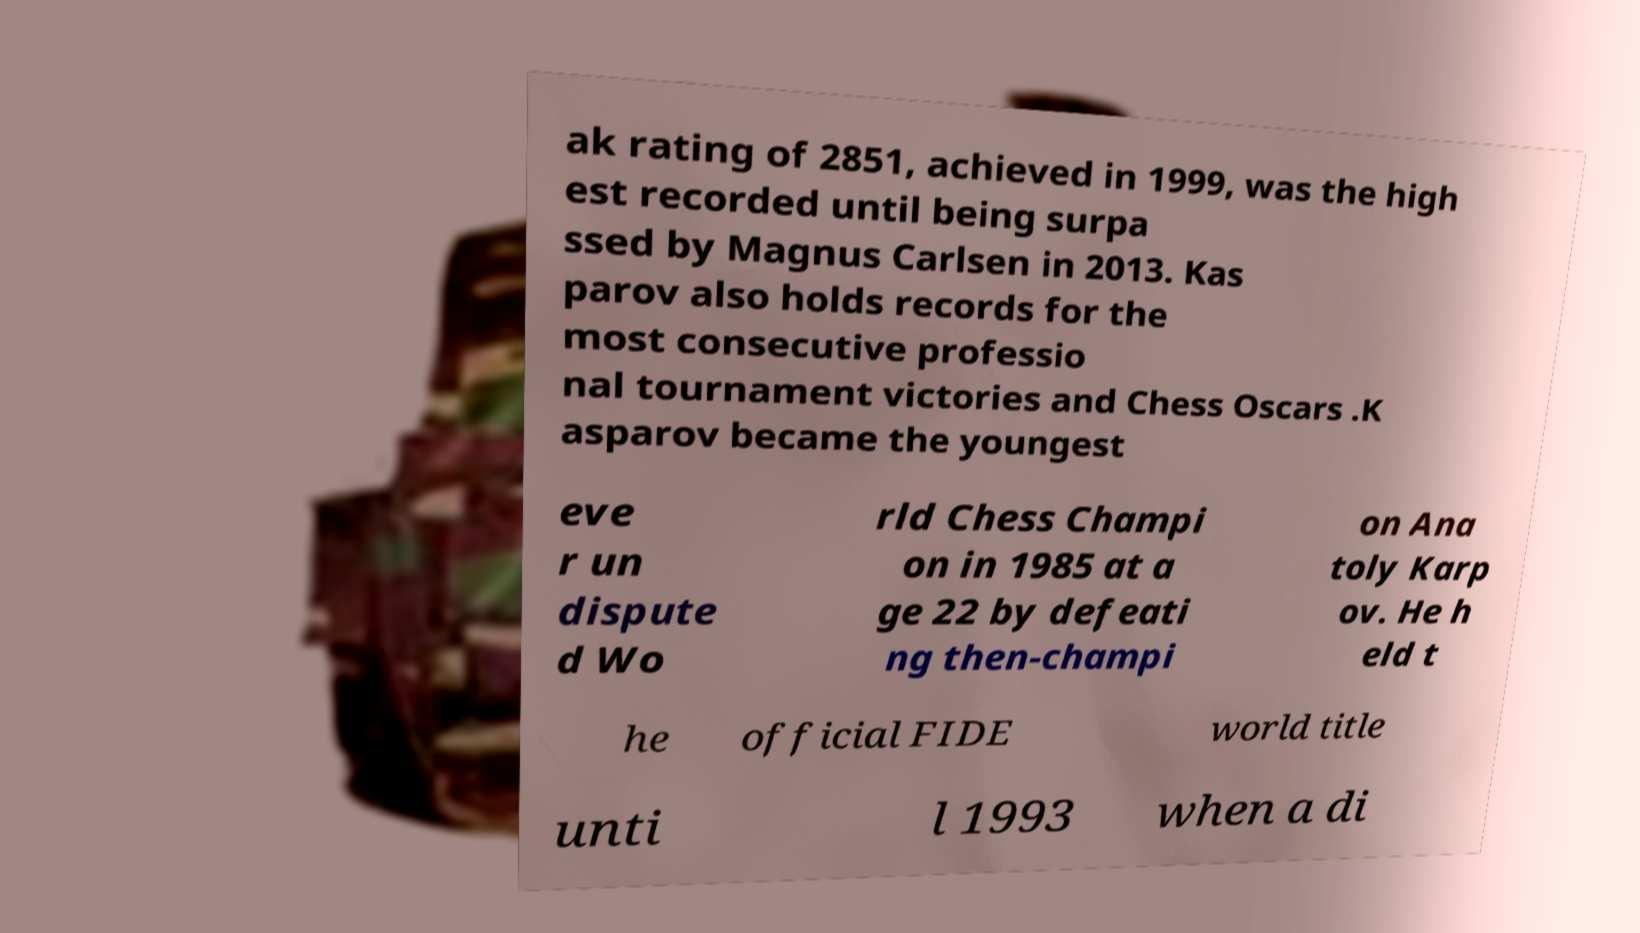Can you accurately transcribe the text from the provided image for me? ak rating of 2851, achieved in 1999, was the high est recorded until being surpa ssed by Magnus Carlsen in 2013. Kas parov also holds records for the most consecutive professio nal tournament victories and Chess Oscars .K asparov became the youngest eve r un dispute d Wo rld Chess Champi on in 1985 at a ge 22 by defeati ng then-champi on Ana toly Karp ov. He h eld t he official FIDE world title unti l 1993 when a di 